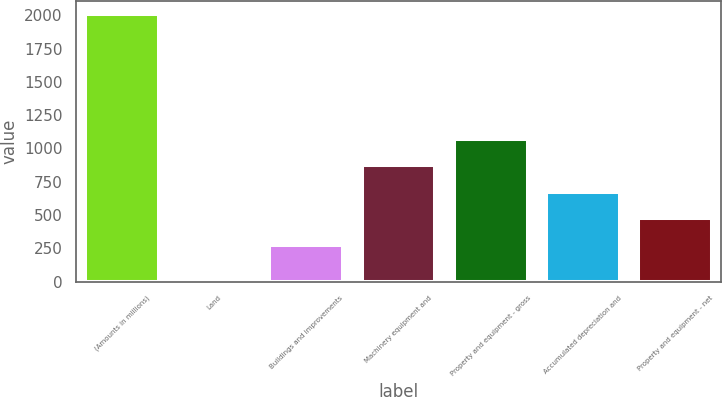Convert chart to OTSL. <chart><loc_0><loc_0><loc_500><loc_500><bar_chart><fcel>(Amounts in millions)<fcel>Land<fcel>Buildings and improvements<fcel>Machinery equipment and<fcel>Property and equipment - gross<fcel>Accumulated depreciation and<fcel>Property and equipment - net<nl><fcel>2011<fcel>19.8<fcel>274.9<fcel>872.26<fcel>1071.38<fcel>673.14<fcel>474.02<nl></chart> 